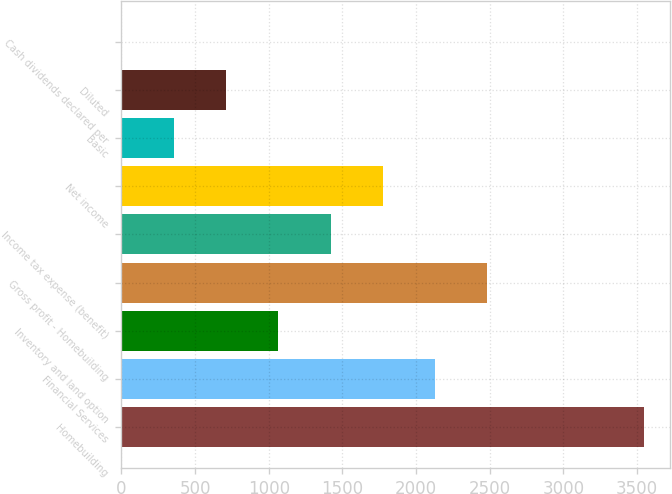<chart> <loc_0><loc_0><loc_500><loc_500><bar_chart><fcel>Homebuilding<fcel>Financial Services<fcel>Inventory and land option<fcel>Gross profit - Homebuilding<fcel>Income tax expense (benefit)<fcel>Net income<fcel>Basic<fcel>Diluted<fcel>Cash dividends declared per<nl><fcel>3549.6<fcel>2129.8<fcel>1064.97<fcel>2484.75<fcel>1419.91<fcel>1774.86<fcel>355.09<fcel>710.03<fcel>0.15<nl></chart> 